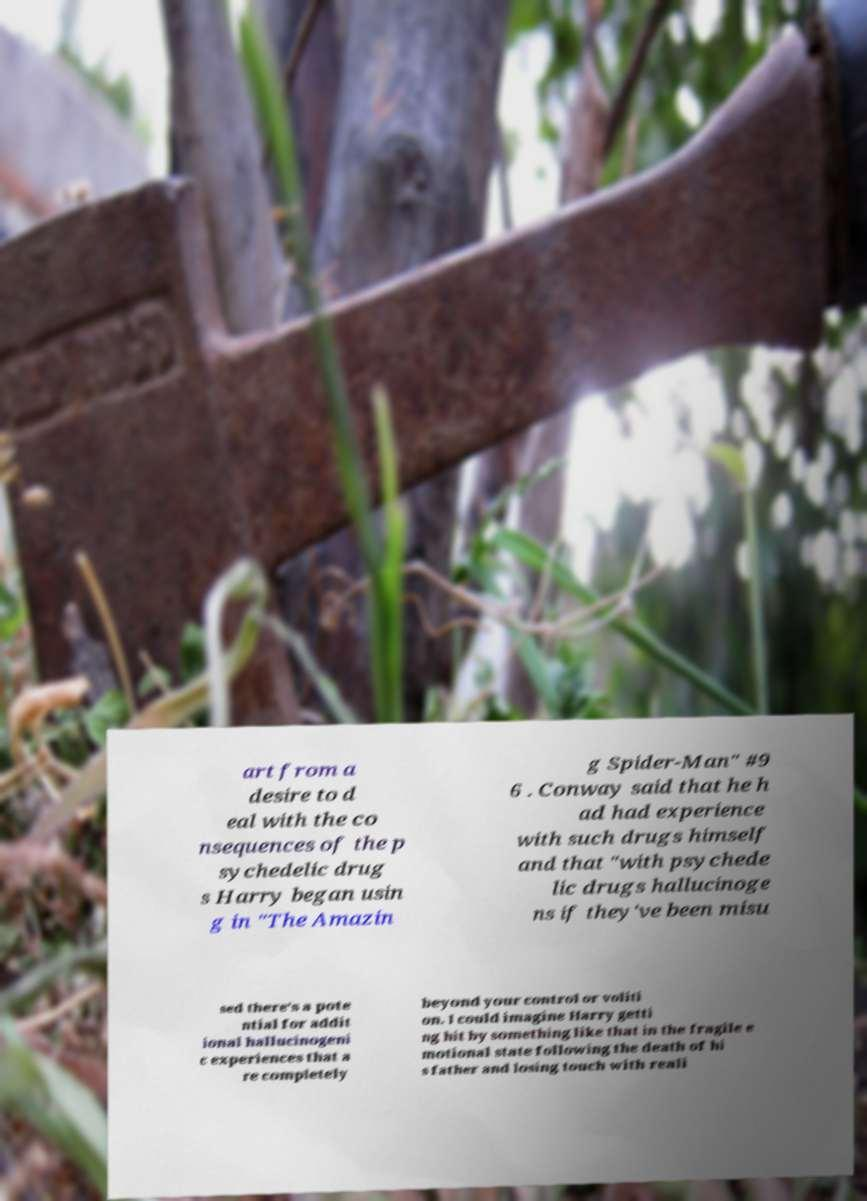I need the written content from this picture converted into text. Can you do that? art from a desire to d eal with the co nsequences of the p sychedelic drug s Harry began usin g in "The Amazin g Spider-Man" #9 6 . Conway said that he h ad had experience with such drugs himself and that "with psychede lic drugs hallucinoge ns if they've been misu sed there's a pote ntial for addit ional hallucinogeni c experiences that a re completely beyond your control or voliti on. I could imagine Harry getti ng hit by something like that in the fragile e motional state following the death of hi s father and losing touch with reali 